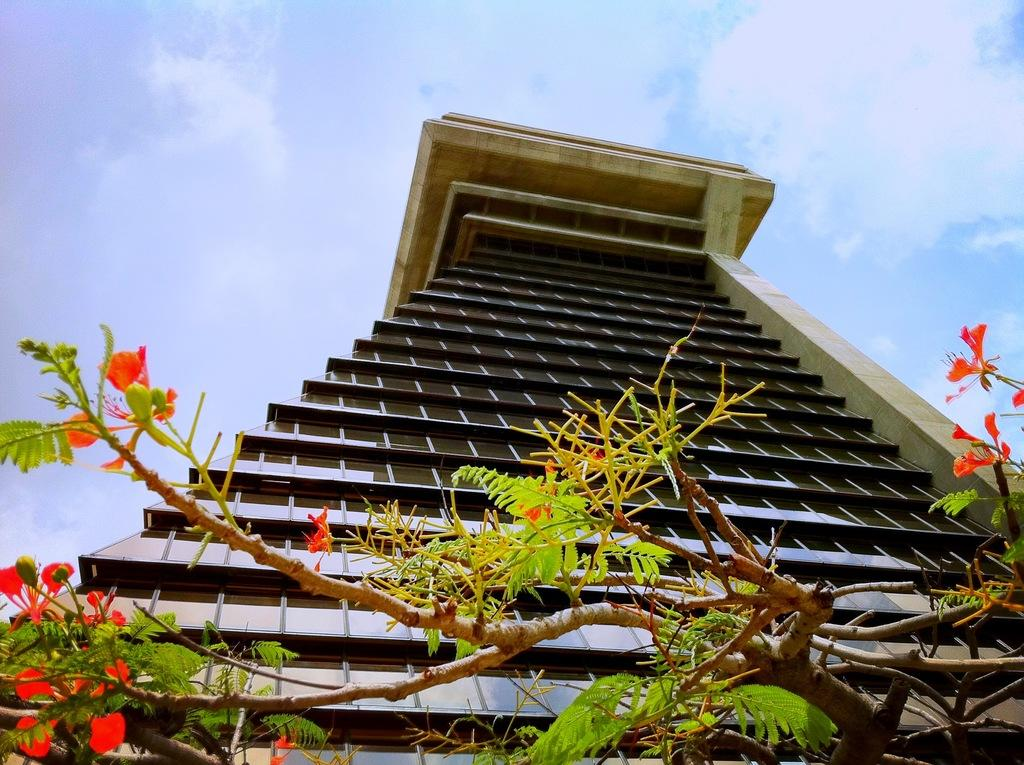What type of natural element is present in the image? There is a tree in the image. What type of man-made structure is present in the image? There is a building in the image. What can be seen in the sky at the top of the image? Clouds are visible in the sky at the top of the image. What design is the bee flying around in the image? There is no bee present in the image, so it cannot be determined what design it might be flying around. 